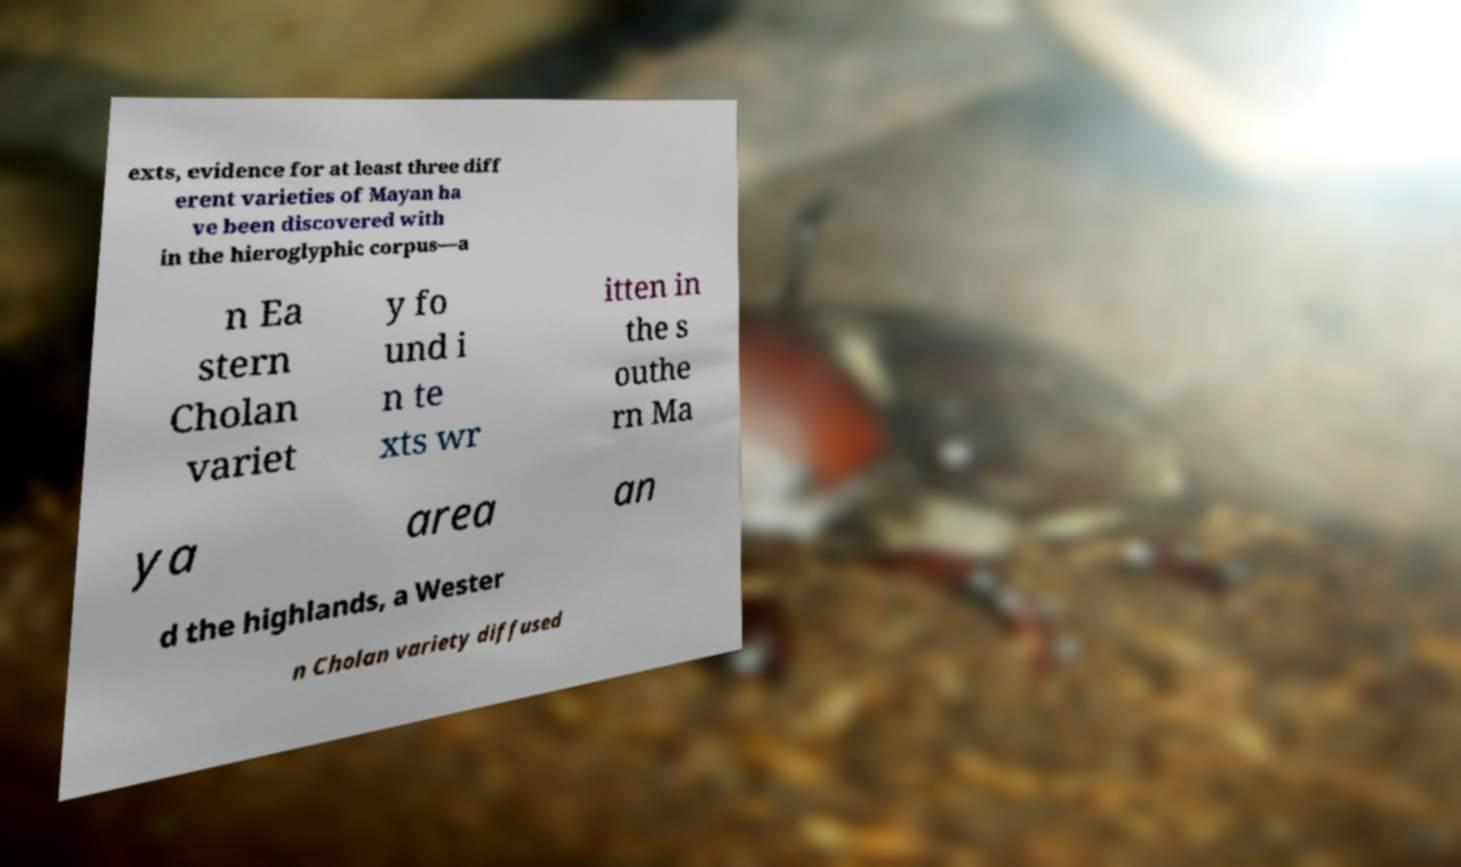Can you read and provide the text displayed in the image?This photo seems to have some interesting text. Can you extract and type it out for me? exts, evidence for at least three diff erent varieties of Mayan ha ve been discovered with in the hieroglyphic corpus—a n Ea stern Cholan variet y fo und i n te xts wr itten in the s outhe rn Ma ya area an d the highlands, a Wester n Cholan variety diffused 